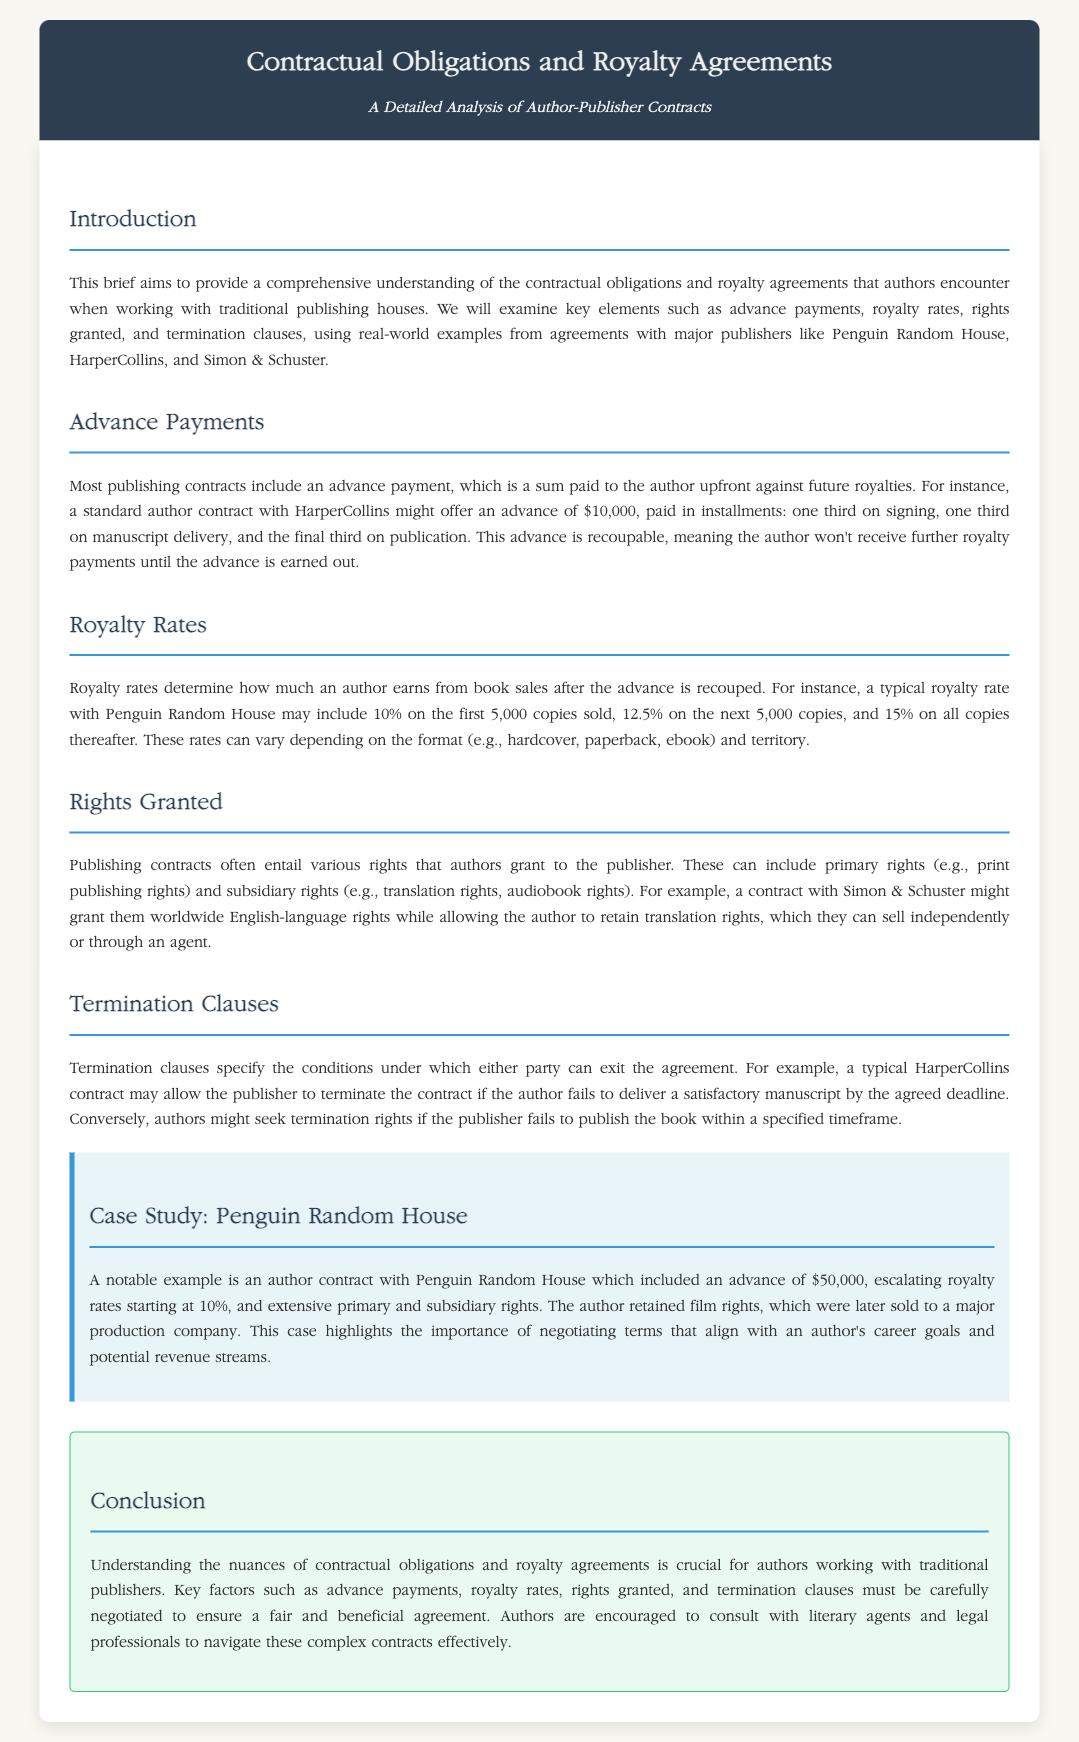What is the purpose of this brief? The brief aims to provide a comprehensive understanding of the contractual obligations and royalty agreements that authors encounter when working with traditional publishing houses.
Answer: Understanding contractual obligations and royalty agreements What is a standard advance payment offered by HarperCollins? A standard author contract with HarperCollins might offer an advance of $10,000.
Answer: $10,000 What percentage is the royalty rate for the first 5,000 copies sold with Penguin Random House? A typical royalty rate with Penguin Random House may include 10% on the first 5,000 copies sold.
Answer: 10% What type of rights do authors often grant to publishers? Authors often grant primary rights and subsidiary rights to the publisher.
Answer: Primary and subsidiary rights What can allow the publisher to terminate a contract with HarperCollins? A typical HarperCollins contract may allow the publisher to terminate the contract if the author fails to deliver a satisfactory manuscript by the agreed deadline.
Answer: Fails to deliver a satisfactory manuscript In the case study of Penguin Random House, what was the advance amount? An author contract with Penguin Random House included an advance of $50,000.
Answer: $50,000 What should authors consult to navigate complex contracts? Authors are encouraged to consult with literary agents and legal professionals.
Answer: Literary agents and legal professionals What might result from retaining film rights in a contract? The author retained film rights, which were later sold to a major production company.
Answer: Sold to a major production company 